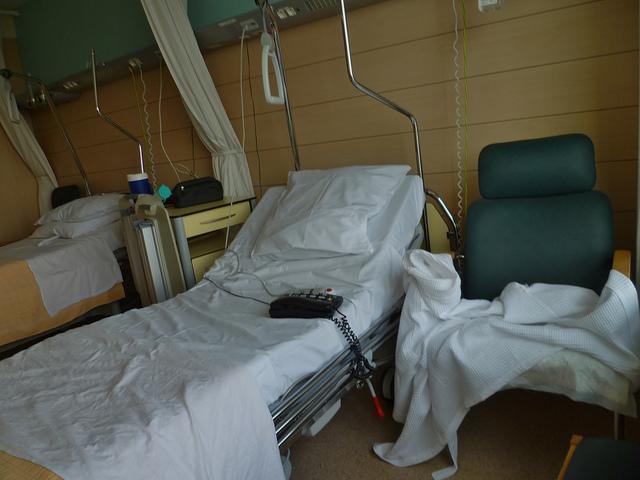How many beds are in the picture?
Give a very brief answer. 2. How many people are wearing helmet?
Give a very brief answer. 0. 